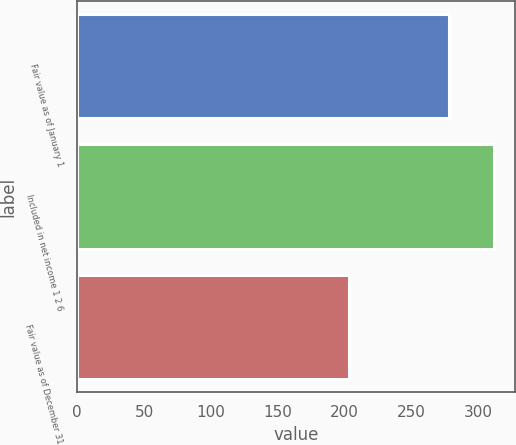Convert chart. <chart><loc_0><loc_0><loc_500><loc_500><bar_chart><fcel>Fair value as of January 1<fcel>Included in net income 1 2 6<fcel>Fair value as of December 31<nl><fcel>278<fcel>312<fcel>203<nl></chart> 